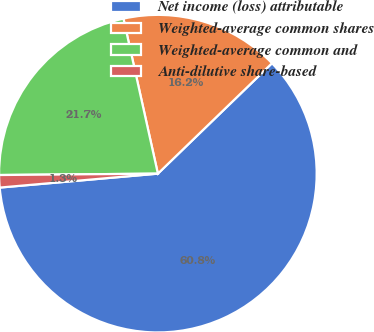Convert chart to OTSL. <chart><loc_0><loc_0><loc_500><loc_500><pie_chart><fcel>Net income (loss) attributable<fcel>Weighted-average common shares<fcel>Weighted-average common and<fcel>Anti-dilutive share-based<nl><fcel>60.84%<fcel>16.24%<fcel>21.66%<fcel>1.26%<nl></chart> 